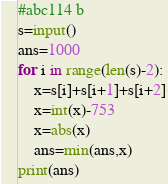<code> <loc_0><loc_0><loc_500><loc_500><_Python_>#abc114 b
s=input()
ans=1000
for i in range(len(s)-2):
    x=s[i]+s[i+1]+s[i+2]
    x=int(x)-753
    x=abs(x)
    ans=min(ans,x)
print(ans)
</code> 